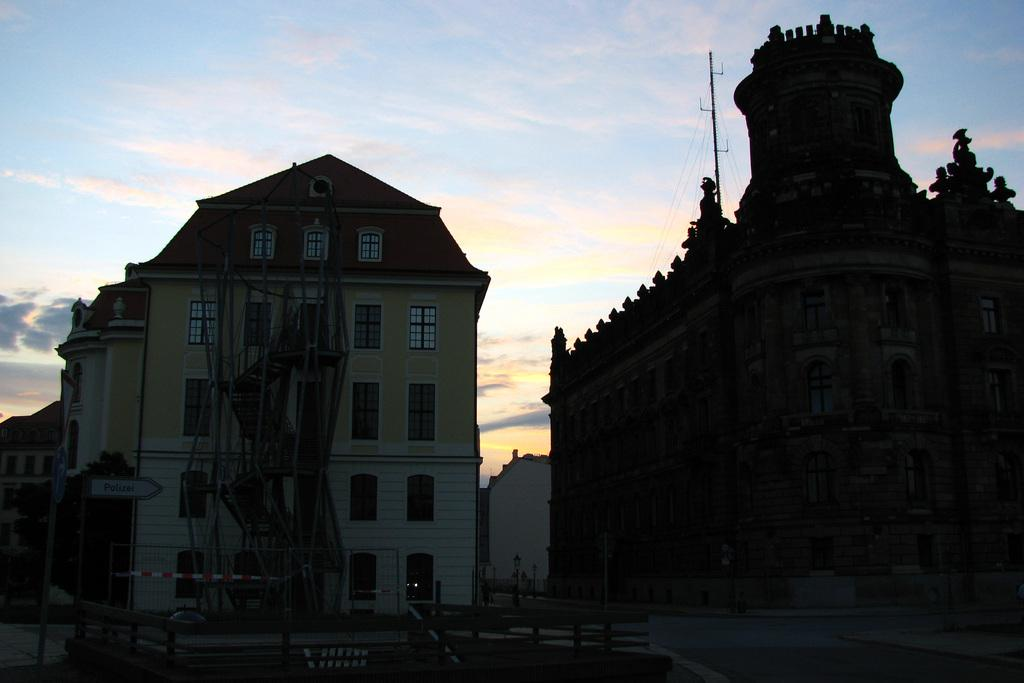What type of structures can be seen in the image? There are buildings in the image. What other objects can be seen in the image besides buildings? There are poles, boards, a railing, and an object visible in the image. What type of vegetation is present in the image? There are trees in the image. What type of surface is visible in the image? There is a road in the image. What can be seen in the background of the image? The sky is visible in the background of the image, and there are clouds in the sky. Is there a veil covering the buildings in the image? No, there is no veil present in the image. What is the chance of winning a prize in the image? There is no mention of a prize or chance in the image. 